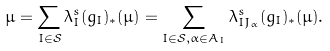<formula> <loc_0><loc_0><loc_500><loc_500>\mu = \sum _ { I \in \mathcal { S } } \lambda _ { I } ^ { s } ( g _ { I } ) _ { * } ( \mu ) = \sum _ { I \in \mathcal { S } , \alpha \in A _ { I } } \lambda _ { I J _ { \alpha } } ^ { s } ( g _ { I } ) _ { * } ( \mu ) .</formula> 